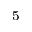<formula> <loc_0><loc_0><loc_500><loc_500>^ { 5 }</formula> 